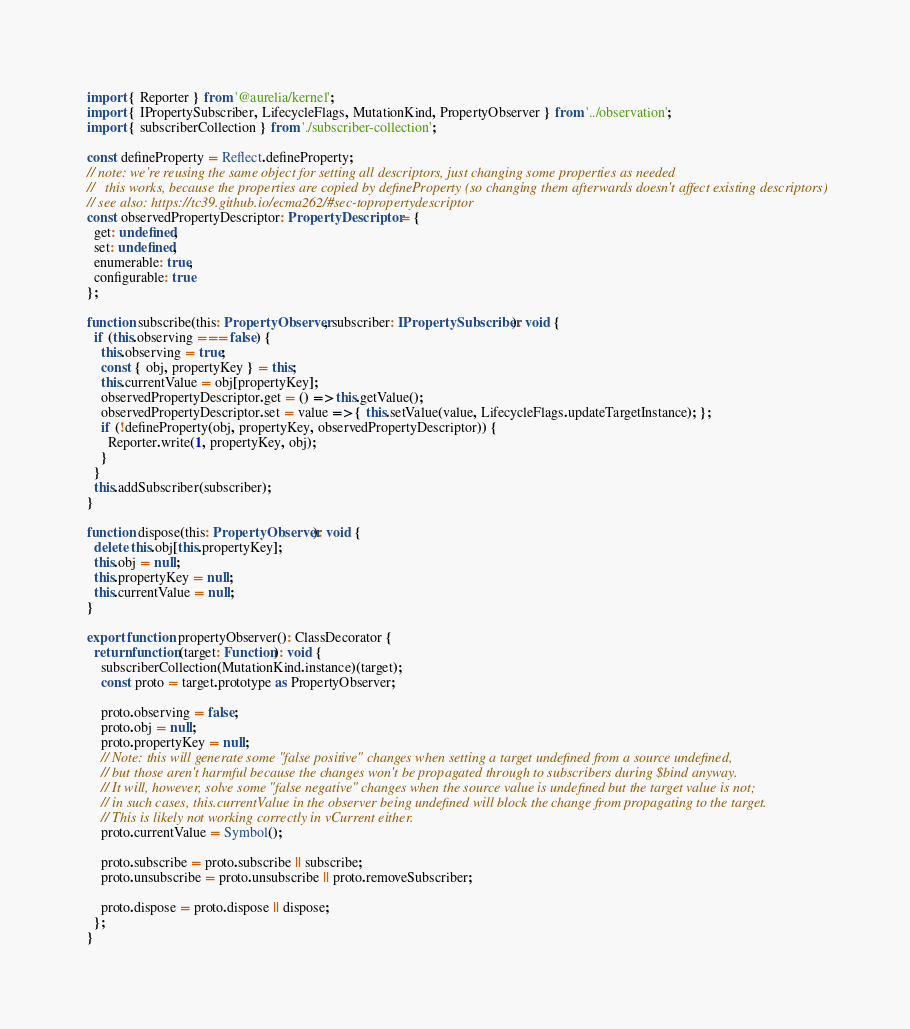<code> <loc_0><loc_0><loc_500><loc_500><_TypeScript_>import { Reporter } from '@aurelia/kernel';
import { IPropertySubscriber, LifecycleFlags, MutationKind, PropertyObserver } from '../observation';
import { subscriberCollection } from './subscriber-collection';

const defineProperty = Reflect.defineProperty;
// note: we're reusing the same object for setting all descriptors, just changing some properties as needed
//   this works, because the properties are copied by defineProperty (so changing them afterwards doesn't affect existing descriptors)
// see also: https://tc39.github.io/ecma262/#sec-topropertydescriptor
const observedPropertyDescriptor: PropertyDescriptor = {
  get: undefined,
  set: undefined,
  enumerable: true,
  configurable: true
};

function subscribe(this: PropertyObserver, subscriber: IPropertySubscriber): void {
  if (this.observing === false) {
    this.observing = true;
    const { obj, propertyKey } = this;
    this.currentValue = obj[propertyKey];
    observedPropertyDescriptor.get = () => this.getValue();
    observedPropertyDescriptor.set = value => { this.setValue(value, LifecycleFlags.updateTargetInstance); };
    if (!defineProperty(obj, propertyKey, observedPropertyDescriptor)) {
      Reporter.write(1, propertyKey, obj);
    }
  }
  this.addSubscriber(subscriber);
}

function dispose(this: PropertyObserver): void {
  delete this.obj[this.propertyKey];
  this.obj = null;
  this.propertyKey = null;
  this.currentValue = null;
}

export function propertyObserver(): ClassDecorator {
  return function(target: Function): void {
    subscriberCollection(MutationKind.instance)(target);
    const proto = target.prototype as PropertyObserver;

    proto.observing = false;
    proto.obj = null;
    proto.propertyKey = null;
    // Note: this will generate some "false positive" changes when setting a target undefined from a source undefined,
    // but those aren't harmful because the changes won't be propagated through to subscribers during $bind anyway.
    // It will, however, solve some "false negative" changes when the source value is undefined but the target value is not;
    // in such cases, this.currentValue in the observer being undefined will block the change from propagating to the target.
    // This is likely not working correctly in vCurrent either.
    proto.currentValue = Symbol();

    proto.subscribe = proto.subscribe || subscribe;
    proto.unsubscribe = proto.unsubscribe || proto.removeSubscriber;

    proto.dispose = proto.dispose || dispose;
  };
}
</code> 